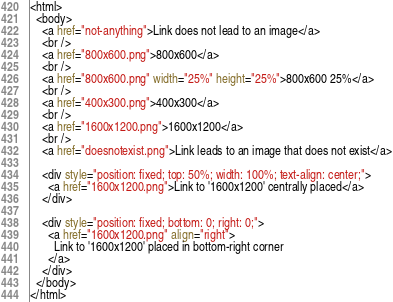<code> <loc_0><loc_0><loc_500><loc_500><_HTML_><html>
  <body>
    <a href="not-anything">Link does not lead to an image</a>
    <br />
    <a href="800x600.png">800x600</a>
    <br />
    <a href="800x600.png" width="25%" height="25%">800x600 25%</a>
    <br />
    <a href="400x300.png">400x300</a>
    <br />
    <a href="1600x1200.png">1600x1200</a>
    <br />
    <a href="doesnotexist.png">Link leads to an image that does not exist</a>
    
    <div style="position: fixed; top: 50%; width: 100%; text-align: center;">
      <a href="1600x1200.png">Link to '1600x1200' centrally placed</a>
    </div>

    <div style="position: fixed; bottom: 0; right: 0;">
      <a href="1600x1200.png" align="right">
        Link to '1600x1200' placed in bottom-right corner
      </a>
    </div>
  </body>
</html></code> 